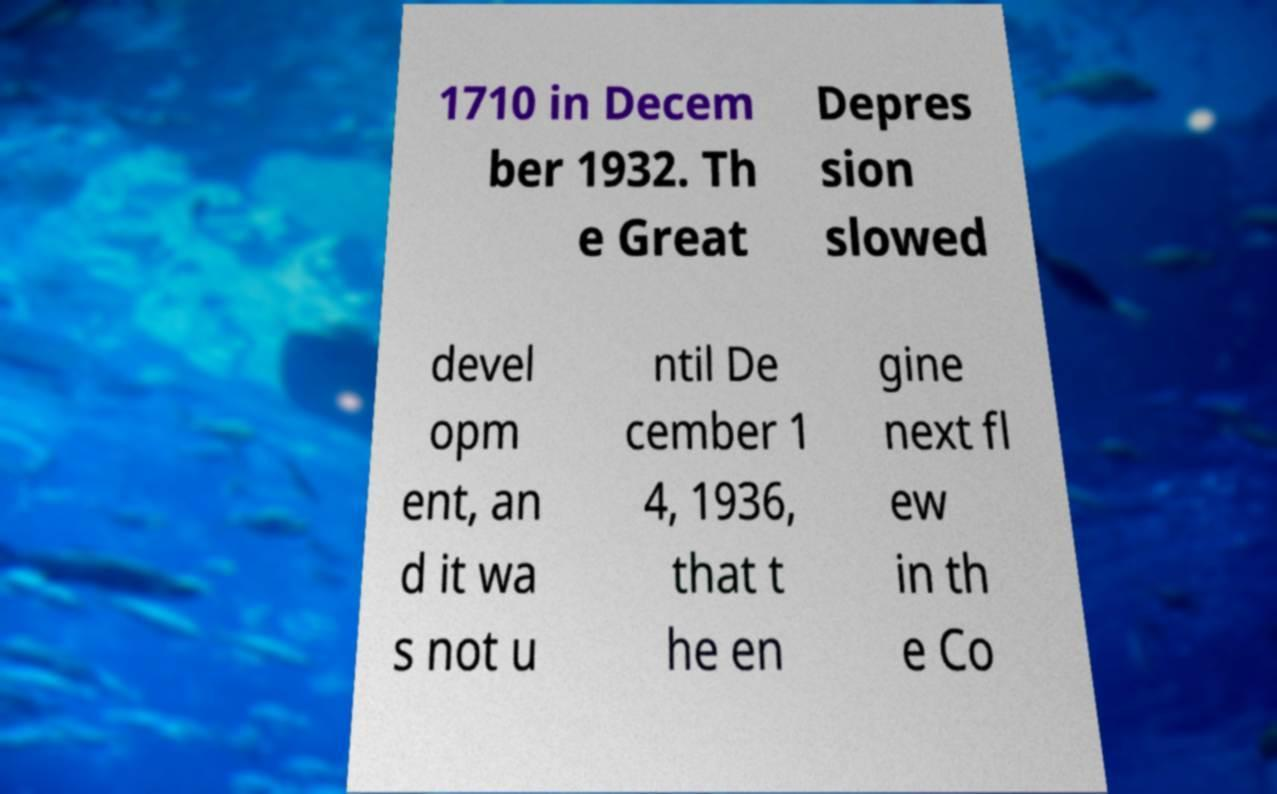What messages or text are displayed in this image? I need them in a readable, typed format. 1710 in Decem ber 1932. Th e Great Depres sion slowed devel opm ent, an d it wa s not u ntil De cember 1 4, 1936, that t he en gine next fl ew in th e Co 